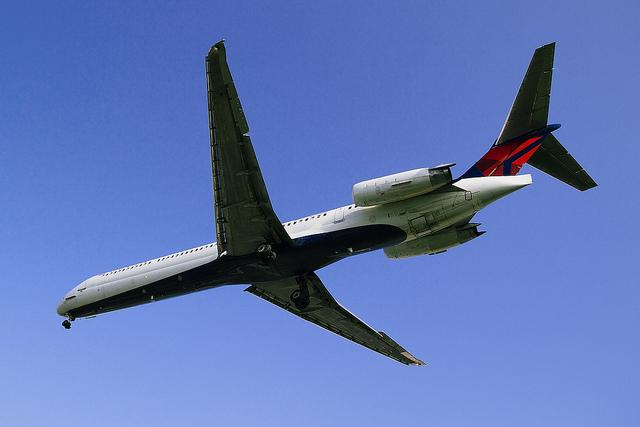Are there clouds visible?
Quick response, please. No. What color is the plane's tail?
Keep it brief. Red. What color is the tail of the plane?
Answer briefly. Red. What kind of planes are these?
Give a very brief answer. Passenger. Is the landing gear up?
Quick response, please. No. What color is the plane?
Keep it brief. White. 